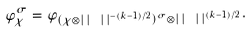Convert formula to latex. <formula><loc_0><loc_0><loc_500><loc_500>\varphi _ { \chi } ^ { \sigma } = \varphi _ { ( \chi \otimes | \, | \ | \, | ^ { - ( k - 1 ) / 2 } ) ^ { \sigma } \otimes | \, | \ | \, | ^ { ( k - 1 ) / 2 } } .</formula> 